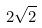<formula> <loc_0><loc_0><loc_500><loc_500>2 \sqrt { 2 }</formula> 